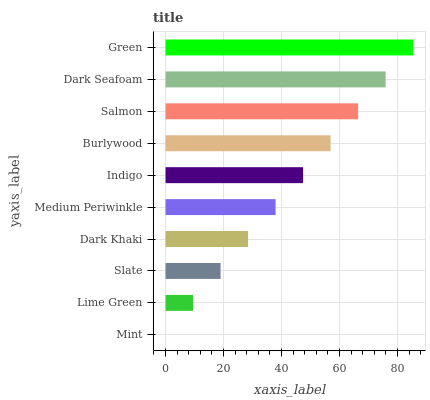Is Mint the minimum?
Answer yes or no. Yes. Is Green the maximum?
Answer yes or no. Yes. Is Lime Green the minimum?
Answer yes or no. No. Is Lime Green the maximum?
Answer yes or no. No. Is Lime Green greater than Mint?
Answer yes or no. Yes. Is Mint less than Lime Green?
Answer yes or no. Yes. Is Mint greater than Lime Green?
Answer yes or no. No. Is Lime Green less than Mint?
Answer yes or no. No. Is Indigo the high median?
Answer yes or no. Yes. Is Medium Periwinkle the low median?
Answer yes or no. Yes. Is Dark Khaki the high median?
Answer yes or no. No. Is Green the low median?
Answer yes or no. No. 